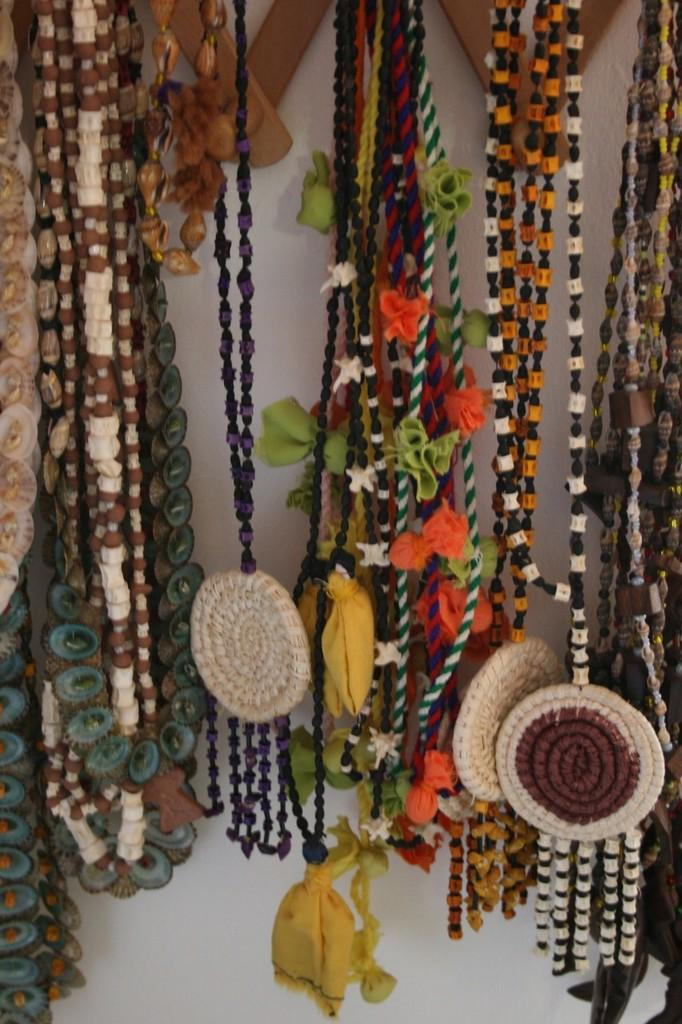What types of objects can be seen in the image? There are decorative items in the image. What color is the background of the image? The background of the image is white. What type of cow can be seen in the image? There is no cow present in the image. What does the caption say in the image? There is no caption present in the image. 